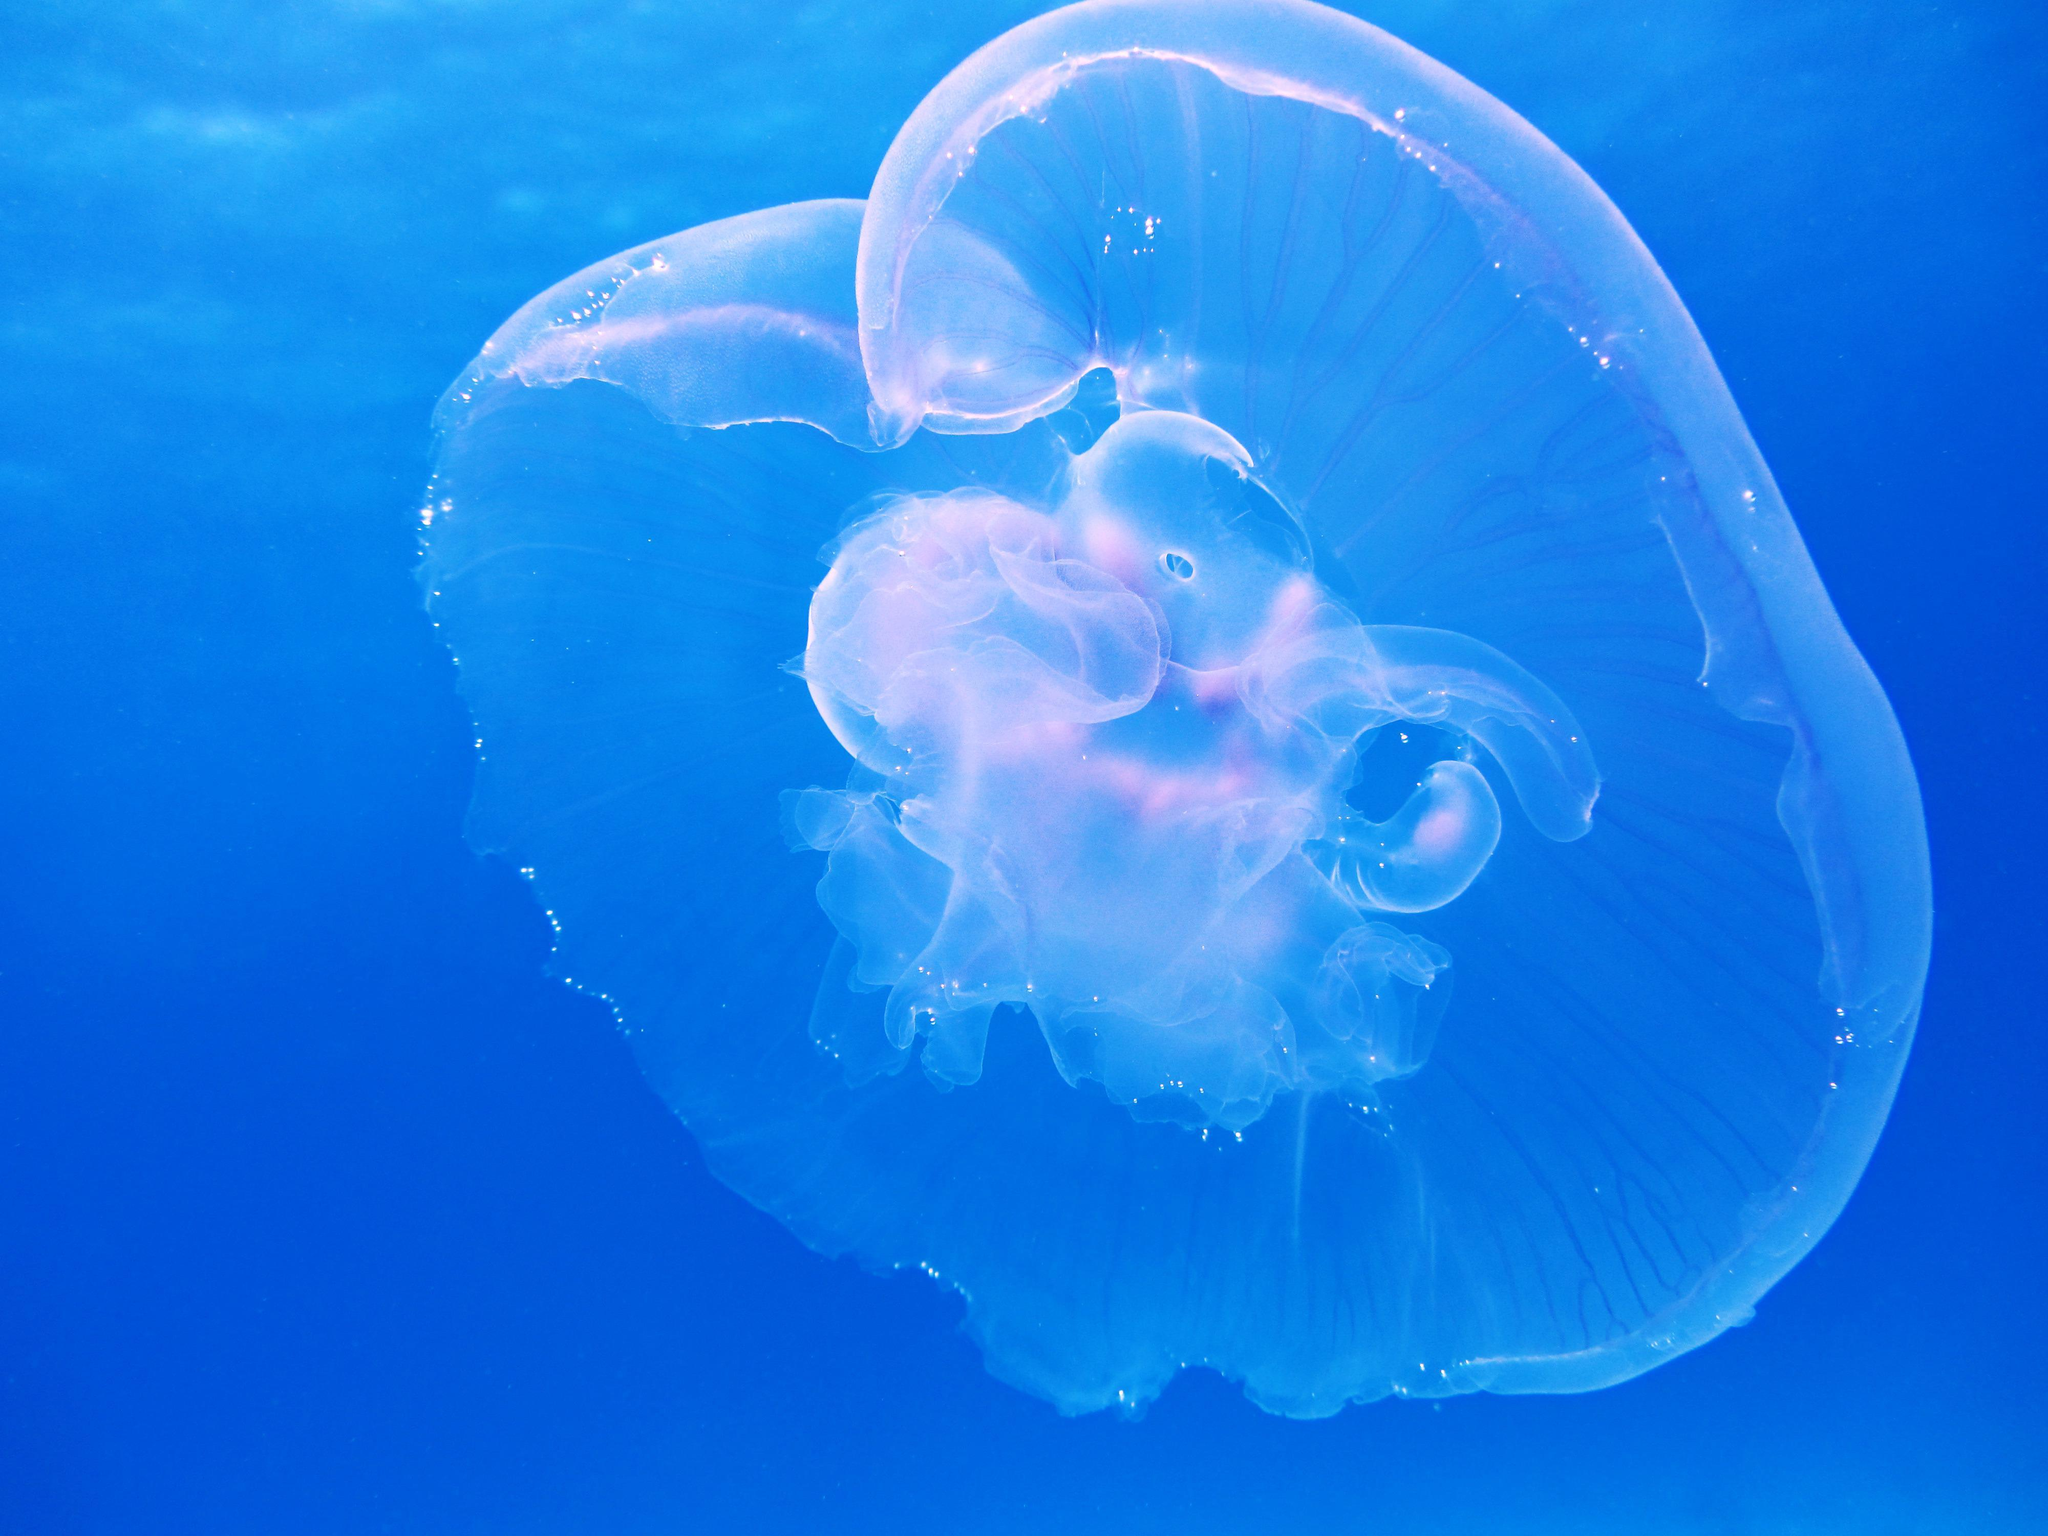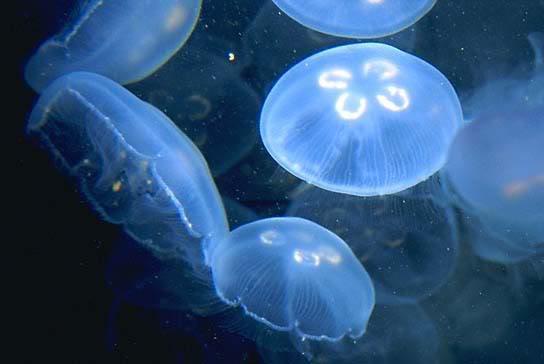The first image is the image on the left, the second image is the image on the right. Analyze the images presented: Is the assertion "There are more than twenty jellyfish." valid? Answer yes or no. No. 